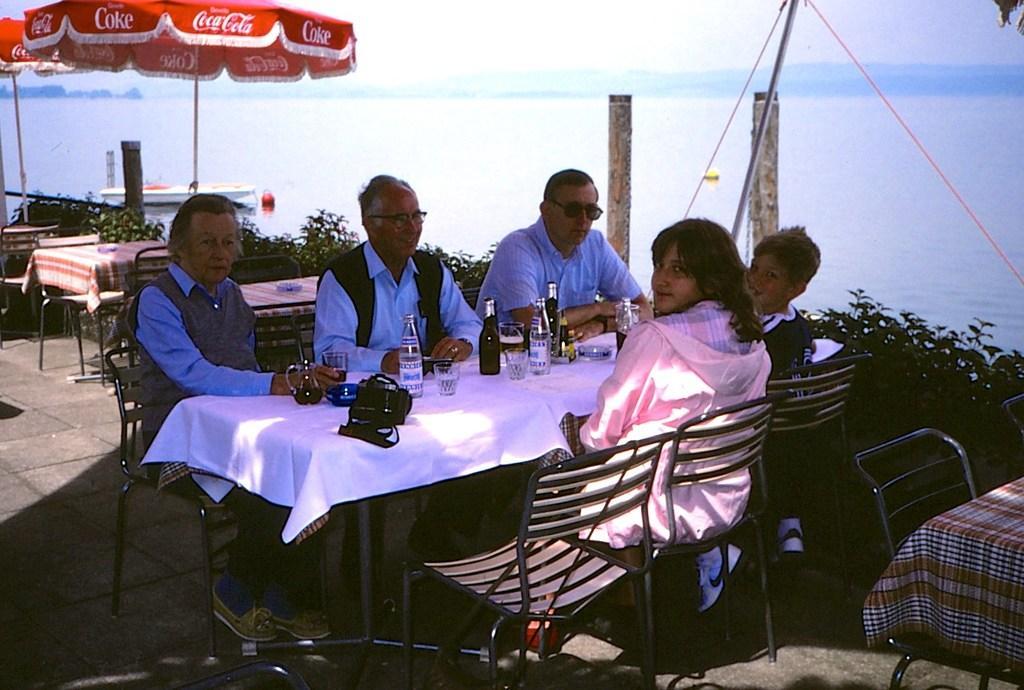Please provide a concise description of this image. In this image it seems like there are five people sitting around the round table. They are sitting to the beach side. On the table there are glass bottles,camera,glass,drink and a curtain. To the left corner their is a umbrella under which their is a table and chairs. To the right corner there are trees which are planted from starting to ending. 